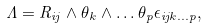<formula> <loc_0><loc_0><loc_500><loc_500>\Lambda = { R _ { i j } } \wedge { { \theta } _ { k } } \wedge \dots { { \theta } _ { p } } { { \epsilon } _ { { i j k } \dots p } } ,</formula> 